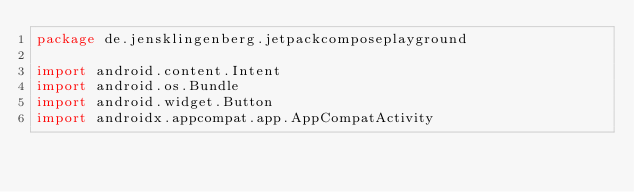Convert code to text. <code><loc_0><loc_0><loc_500><loc_500><_Kotlin_>package de.jensklingenberg.jetpackcomposeplayground

import android.content.Intent
import android.os.Bundle
import android.widget.Button
import androidx.appcompat.app.AppCompatActivity</code> 